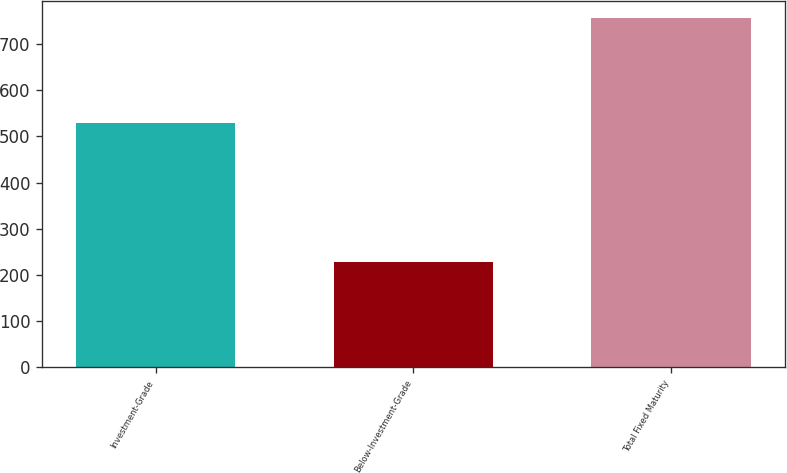Convert chart. <chart><loc_0><loc_0><loc_500><loc_500><bar_chart><fcel>Investment-Grade<fcel>Below-Investment-Grade<fcel>Total Fixed Maturity<nl><fcel>529.5<fcel>226.9<fcel>756.4<nl></chart> 